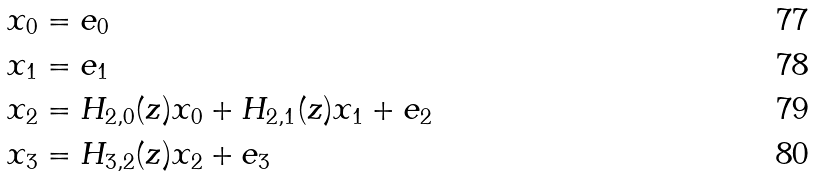<formula> <loc_0><loc_0><loc_500><loc_500>& x _ { 0 } = e _ { 0 } \\ & x _ { 1 } = e _ { 1 } \\ & x _ { 2 } = H _ { 2 , 0 } ( z ) x _ { 0 } + H _ { 2 , 1 } ( z ) x _ { 1 } + e _ { 2 } \\ & x _ { 3 } = H _ { 3 , 2 } ( z ) x _ { 2 } + e _ { 3 }</formula> 